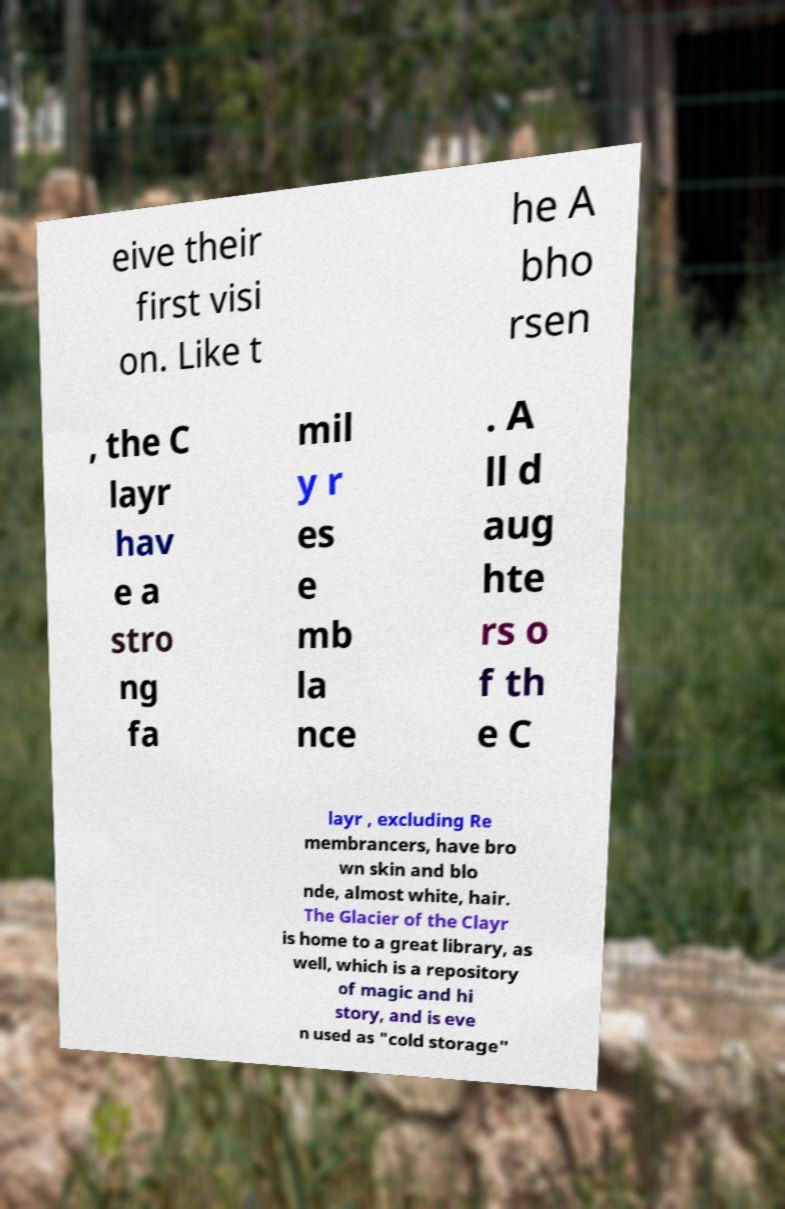Could you assist in decoding the text presented in this image and type it out clearly? eive their first visi on. Like t he A bho rsen , the C layr hav e a stro ng fa mil y r es e mb la nce . A ll d aug hte rs o f th e C layr , excluding Re membrancers, have bro wn skin and blo nde, almost white, hair. The Glacier of the Clayr is home to a great library, as well, which is a repository of magic and hi story, and is eve n used as "cold storage" 